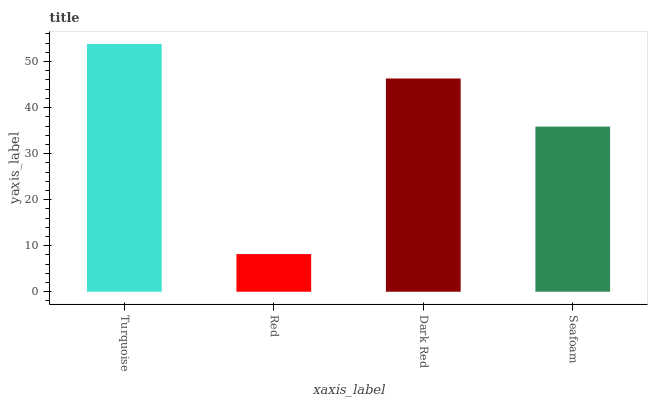Is Red the minimum?
Answer yes or no. Yes. Is Turquoise the maximum?
Answer yes or no. Yes. Is Dark Red the minimum?
Answer yes or no. No. Is Dark Red the maximum?
Answer yes or no. No. Is Dark Red greater than Red?
Answer yes or no. Yes. Is Red less than Dark Red?
Answer yes or no. Yes. Is Red greater than Dark Red?
Answer yes or no. No. Is Dark Red less than Red?
Answer yes or no. No. Is Dark Red the high median?
Answer yes or no. Yes. Is Seafoam the low median?
Answer yes or no. Yes. Is Turquoise the high median?
Answer yes or no. No. Is Turquoise the low median?
Answer yes or no. No. 